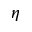<formula> <loc_0><loc_0><loc_500><loc_500>\eta</formula> 